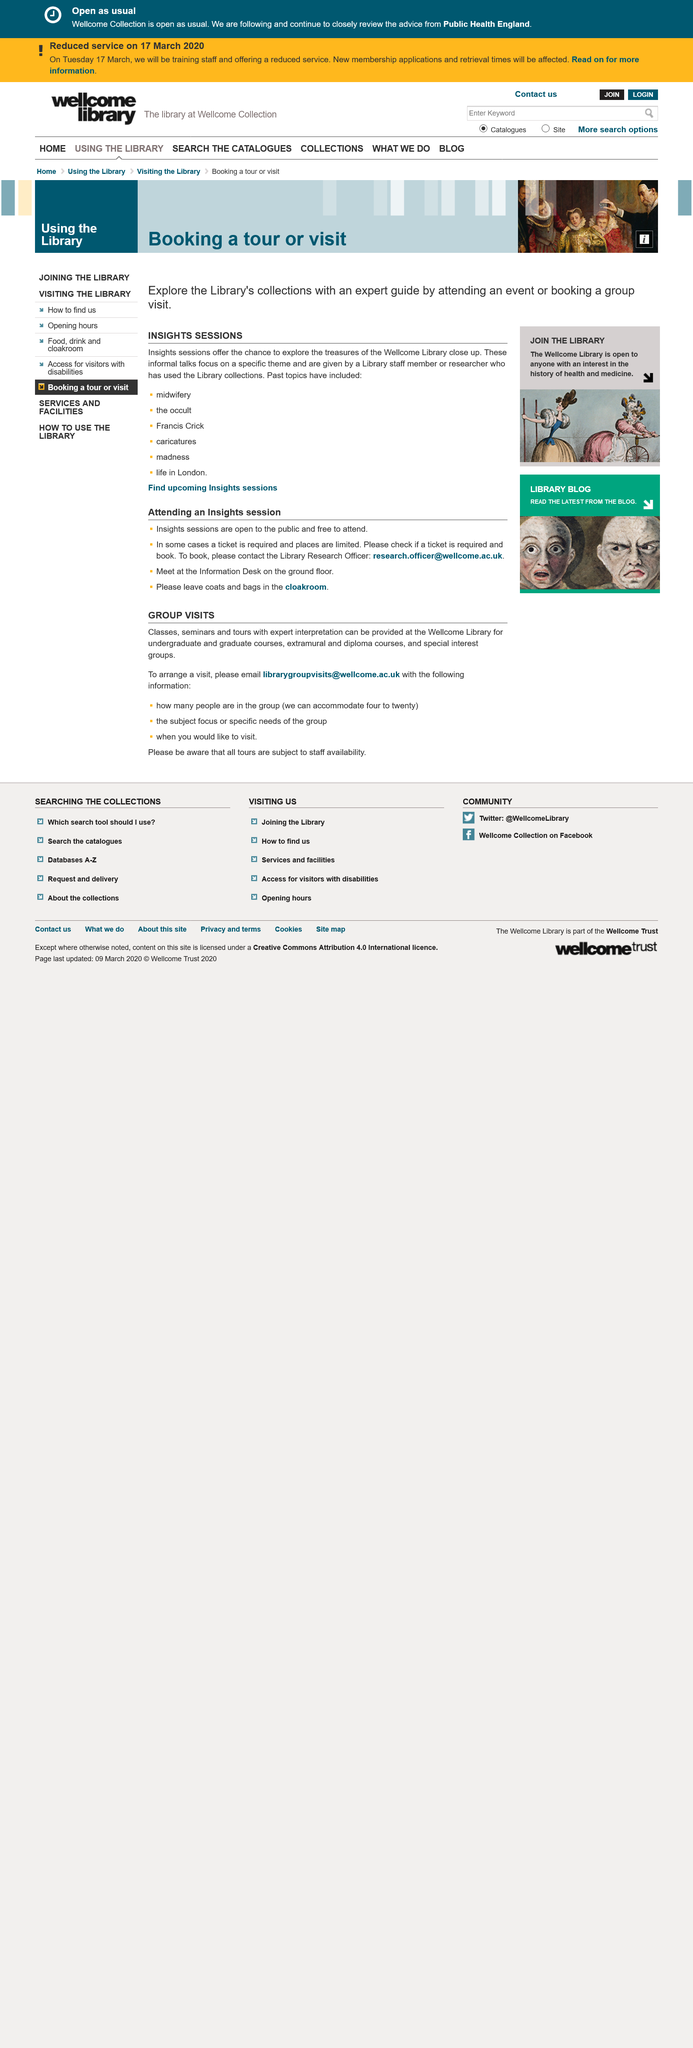Specify some key components in this picture. To arrange a visit to the Wellcome Library, it is necessary to provide information including the number of people in the group, the subject focus or specific needs of the group, and the desired date and time of the visit. The Wellcome Library can accommodate a maximum of four to twenty people on a visit. To schedule a visit to the Wellcome Library, please email the following contact: librarygroupvisits@wellcome.ac.uk. 